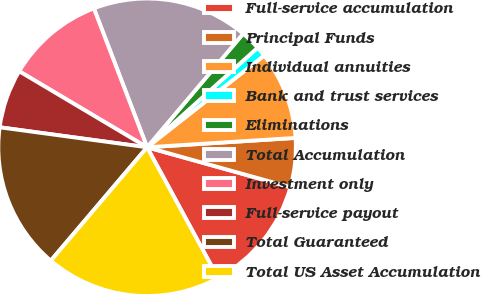Convert chart to OTSL. <chart><loc_0><loc_0><loc_500><loc_500><pie_chart><fcel>Full-service accumulation<fcel>Principal Funds<fcel>Individual annuities<fcel>Bank and trust services<fcel>Eliminations<fcel>Total Accumulation<fcel>Investment only<fcel>Full-service payout<fcel>Total Guaranteed<fcel>Total US Asset Accumulation<nl><fcel>12.76%<fcel>5.33%<fcel>9.58%<fcel>1.09%<fcel>2.15%<fcel>17.0%<fcel>10.64%<fcel>6.39%<fcel>15.94%<fcel>19.12%<nl></chart> 